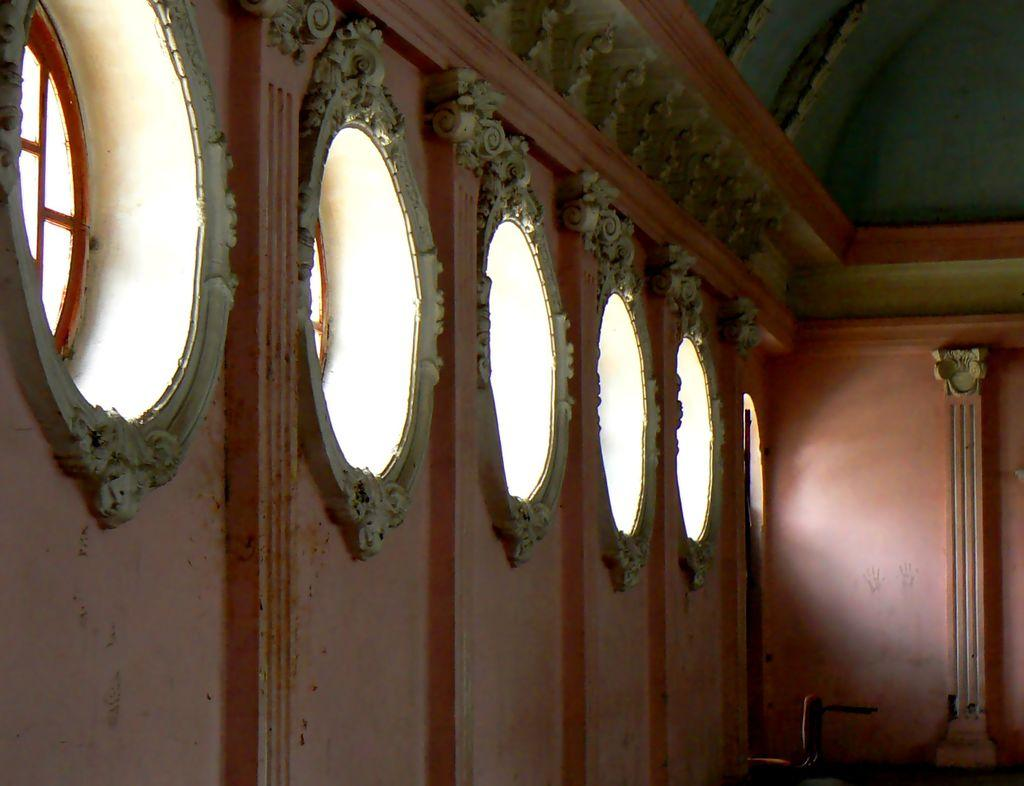What type of structure can be seen in the image? There is a wall in the image. What architectural features are present in the image? There are windows and pillars in the image. Who is the creator of the dust visible in the image? There is no dust visible in the image, so it is not possible to determine the creator. 